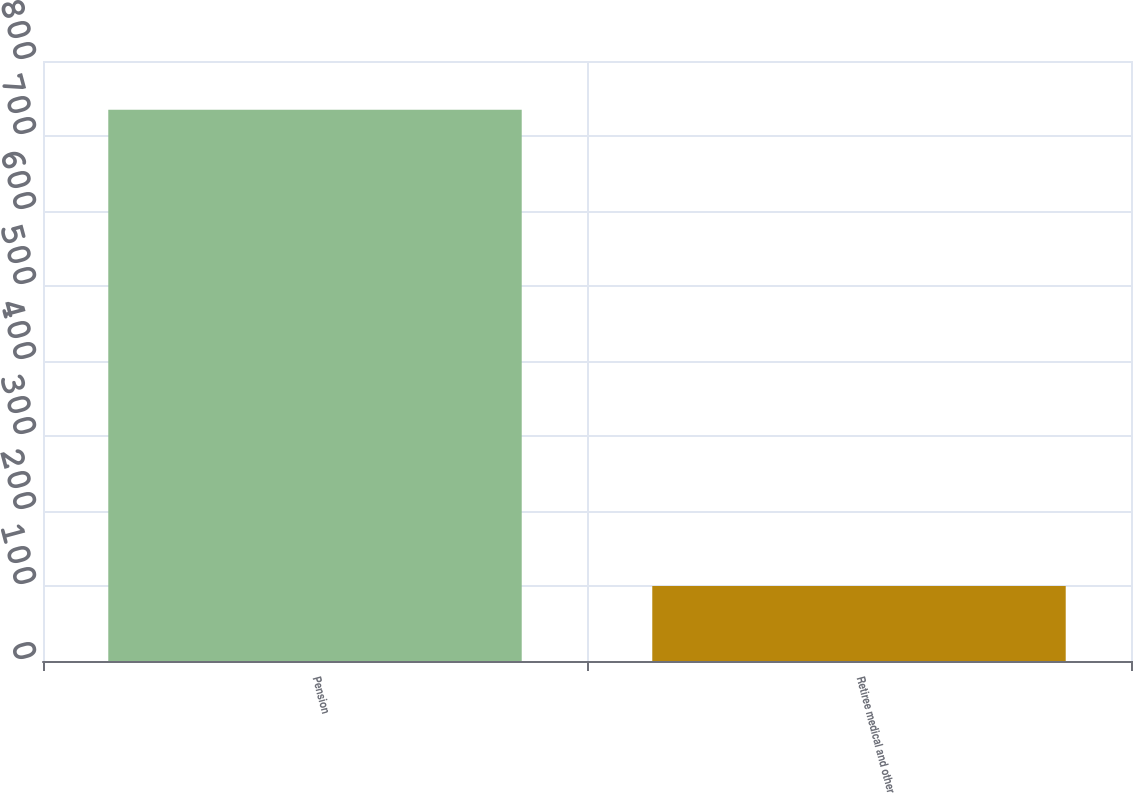<chart> <loc_0><loc_0><loc_500><loc_500><bar_chart><fcel>Pension<fcel>Retiree medical and other<nl><fcel>735<fcel>100<nl></chart> 